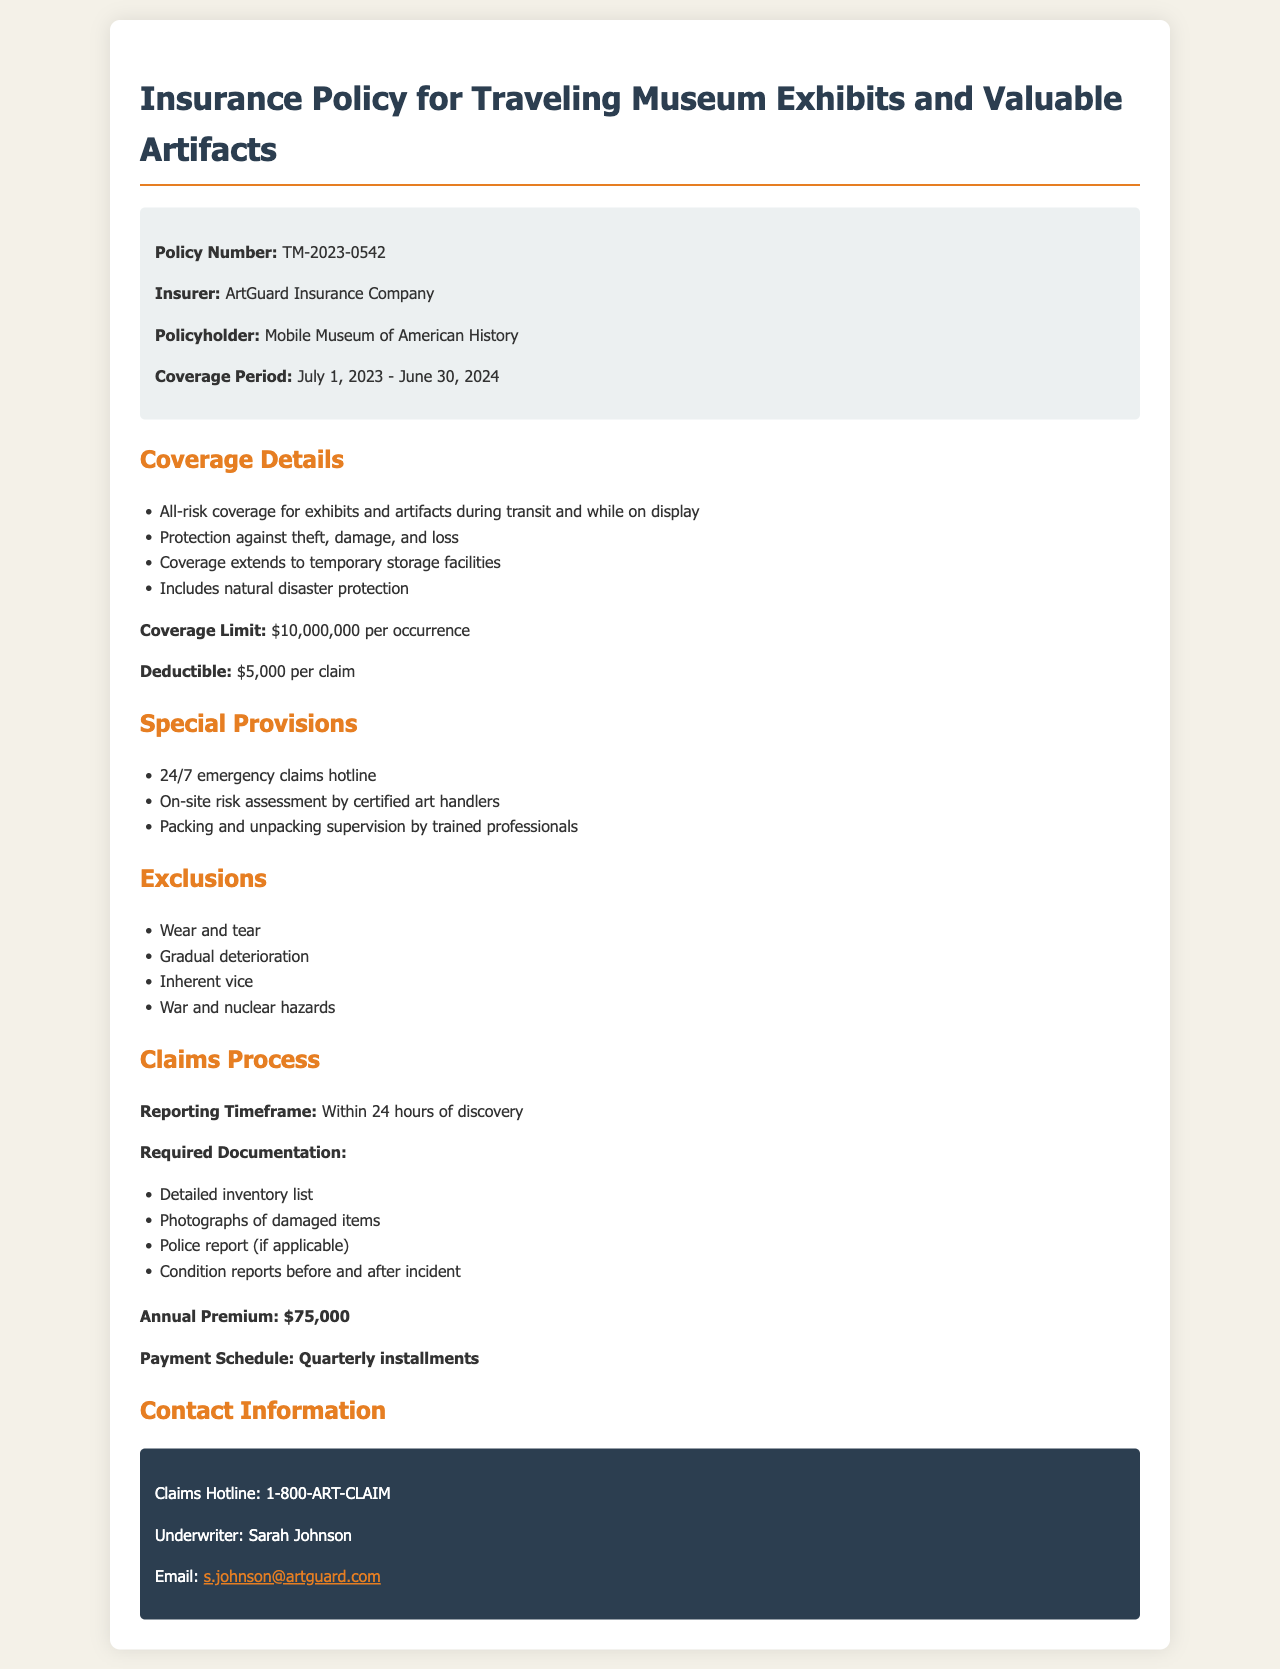What is the policy number? The policy number is a specific identifier for this insurance document.
Answer: TM-2023-0542 Who is the insurer? The insurer is the company providing the insurance policy in the document.
Answer: ArtGuard Insurance Company What is the coverage limit? The coverage limit indicates the maximum amount the insurer will pay for a covered incident.
Answer: $10,000,000 per occurrence What is the deductible amount? The deductible is the amount the policyholder must pay out of pocket before the insurer covers any claims.
Answer: $5,000 per claim What is the duration of the coverage period? The coverage period specifies the start and end dates of the insurance policy's validity.
Answer: July 1, 2023 - June 30, 2024 What are the exclusions listed? The exclusions detail circumstances or items that are not covered by the policy.
Answer: Wear and tear, Gradual deterioration, Inherent vice, War and nuclear hazards What is the annual premium? The annual premium is the total amount charged for maintaining the insurance coverage for a year.
Answer: $75,000 What should be included in the required documentation for claims? Required documentation lists specific items needed to process a claim after an incident occurs.
Answer: Detailed inventory list, Photographs of damaged items, Police report (if applicable), Condition reports before and after incident What special provision involves risk assessment? This provision indicates a specific action taken to assess the risks associated with transporting and displaying art.
Answer: On-site risk assessment by certified art handlers 